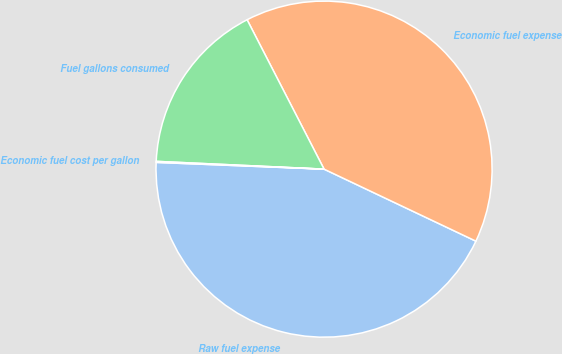Convert chart. <chart><loc_0><loc_0><loc_500><loc_500><pie_chart><fcel>Raw fuel expense<fcel>Economic fuel expense<fcel>Fuel gallons consumed<fcel>Economic fuel cost per gallon<nl><fcel>43.59%<fcel>39.62%<fcel>16.69%<fcel>0.1%<nl></chart> 